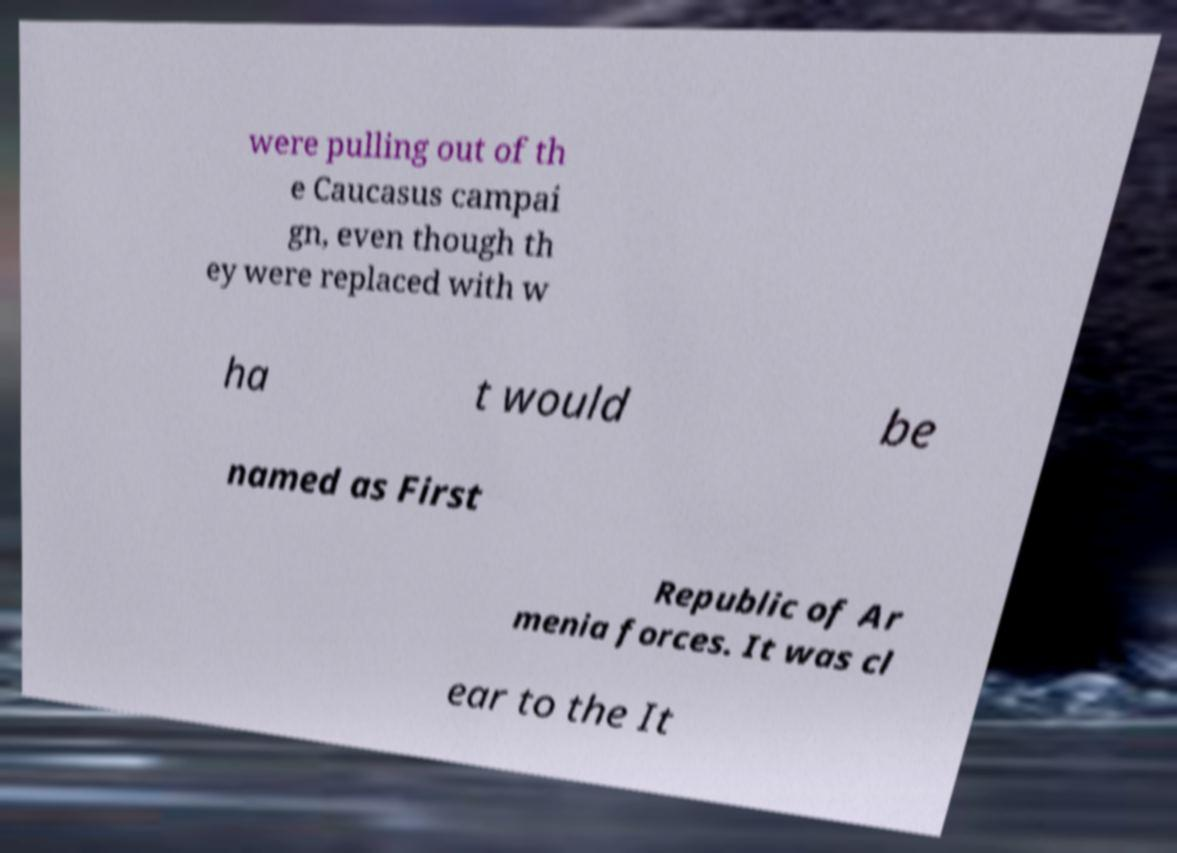I need the written content from this picture converted into text. Can you do that? were pulling out of th e Caucasus campai gn, even though th ey were replaced with w ha t would be named as First Republic of Ar menia forces. It was cl ear to the It 